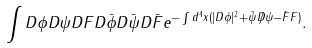<formula> <loc_0><loc_0><loc_500><loc_500>\int D \phi D \psi D F D \bar { \phi } D \bar { \psi } D \bar { F } e ^ { - \int d ^ { 4 } x ( | D \phi | ^ { 2 } + \bar { \psi } \not D \psi - \bar { F } F ) } .</formula> 